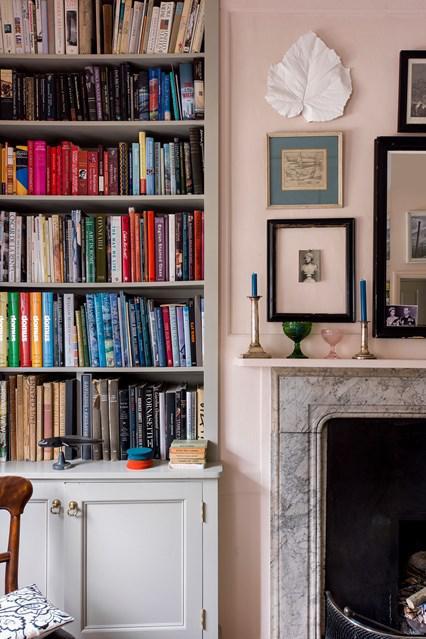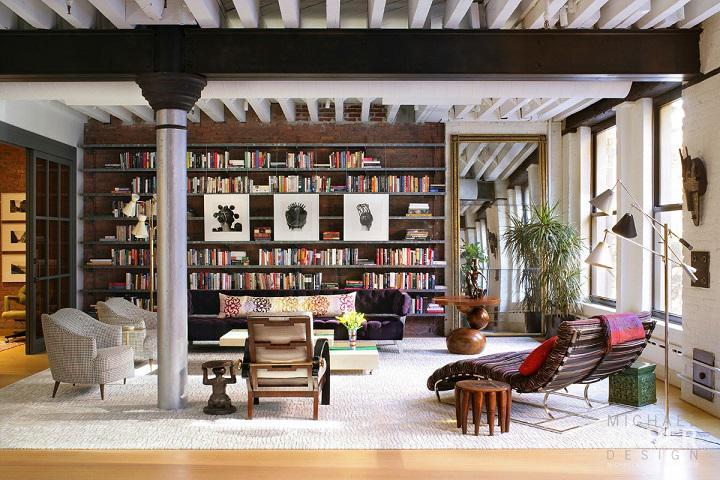The first image is the image on the left, the second image is the image on the right. Analyze the images presented: Is the assertion "A green plant with fanning leaves is near a backless and sideless set of vertical shelves." valid? Answer yes or no. No. The first image is the image on the left, the second image is the image on the right. Analyze the images presented: Is the assertion "A ceiling lamp that hangs over a room is glass-like." valid? Answer yes or no. No. 